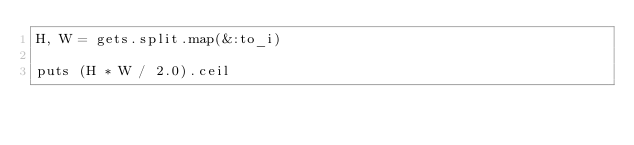Convert code to text. <code><loc_0><loc_0><loc_500><loc_500><_Ruby_>H, W = gets.split.map(&:to_i)

puts (H * W / 2.0).ceil</code> 